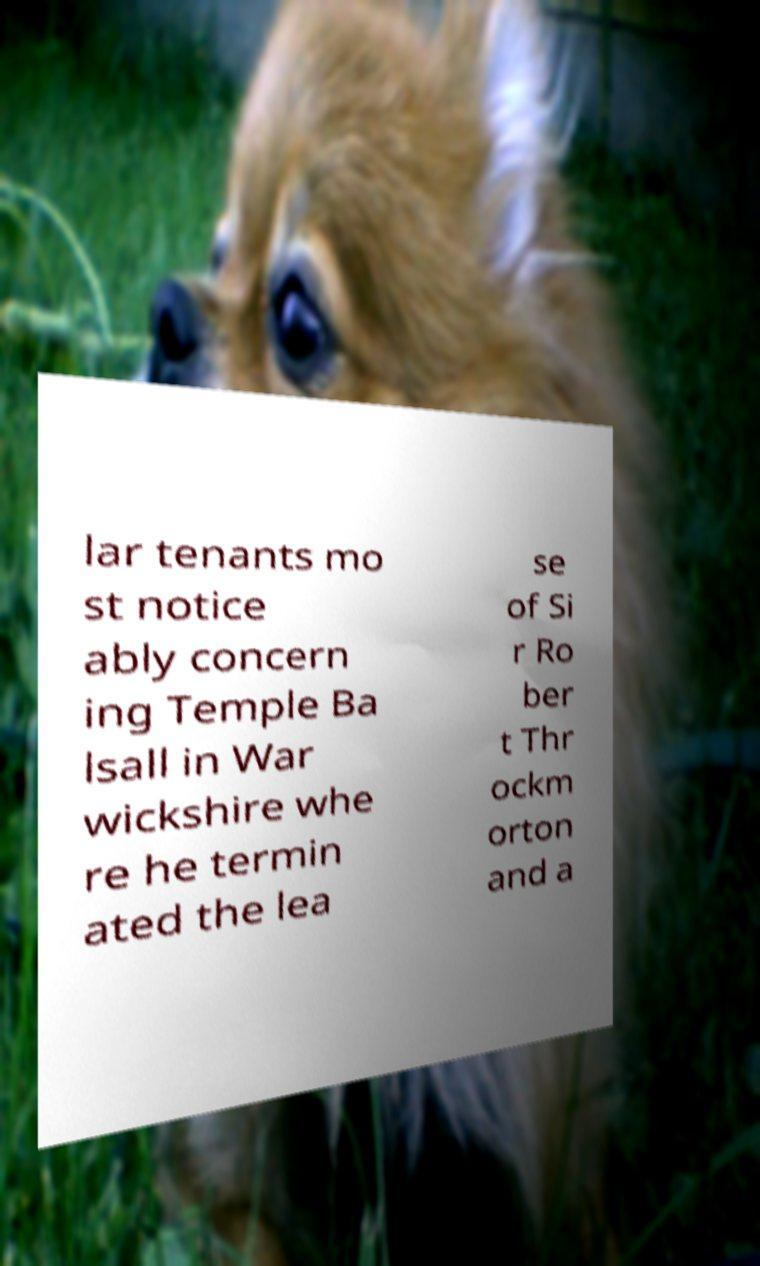Can you read and provide the text displayed in the image?This photo seems to have some interesting text. Can you extract and type it out for me? lar tenants mo st notice ably concern ing Temple Ba lsall in War wickshire whe re he termin ated the lea se of Si r Ro ber t Thr ockm orton and a 